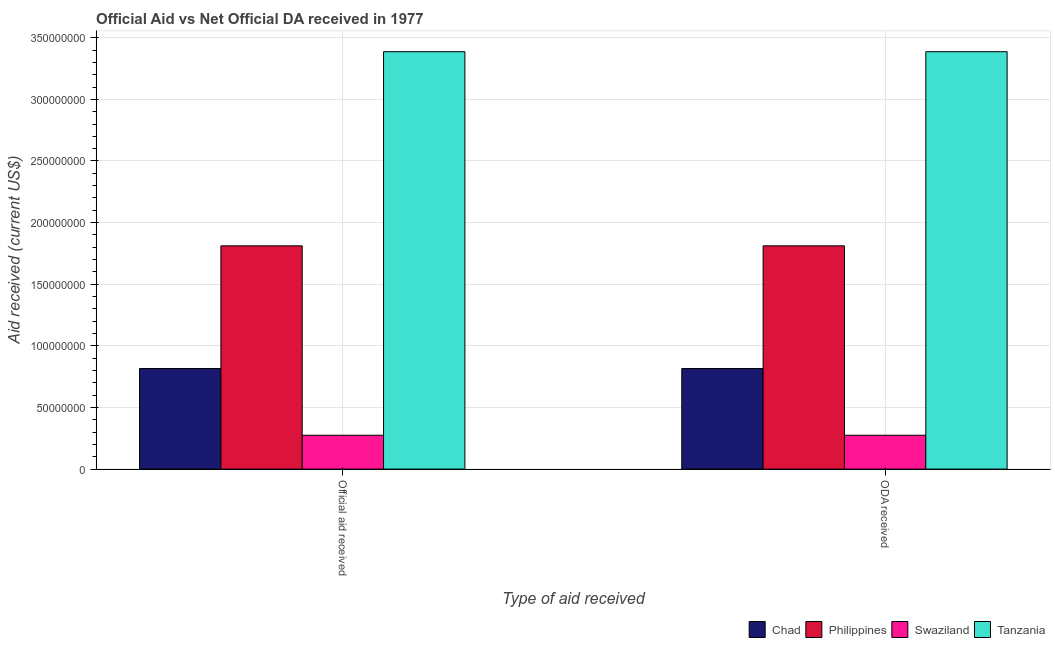How many different coloured bars are there?
Ensure brevity in your answer.  4. How many groups of bars are there?
Provide a succinct answer. 2. Are the number of bars per tick equal to the number of legend labels?
Ensure brevity in your answer.  Yes. Are the number of bars on each tick of the X-axis equal?
Your answer should be compact. Yes. How many bars are there on the 1st tick from the left?
Provide a short and direct response. 4. What is the label of the 2nd group of bars from the left?
Offer a very short reply. ODA received. What is the official aid received in Philippines?
Offer a very short reply. 1.81e+08. Across all countries, what is the maximum oda received?
Your answer should be compact. 3.39e+08. Across all countries, what is the minimum official aid received?
Provide a succinct answer. 2.75e+07. In which country was the oda received maximum?
Offer a terse response. Tanzania. In which country was the oda received minimum?
Give a very brief answer. Swaziland. What is the total oda received in the graph?
Provide a succinct answer. 6.29e+08. What is the difference between the official aid received in Philippines and that in Chad?
Provide a succinct answer. 9.96e+07. What is the difference between the oda received in Swaziland and the official aid received in Philippines?
Provide a succinct answer. -1.54e+08. What is the average official aid received per country?
Make the answer very short. 1.57e+08. In how many countries, is the oda received greater than 20000000 US$?
Your answer should be compact. 4. What is the ratio of the official aid received in Philippines to that in Tanzania?
Your answer should be very brief. 0.53. In how many countries, is the official aid received greater than the average official aid received taken over all countries?
Your answer should be very brief. 2. What does the 1st bar from the left in ODA received represents?
Offer a very short reply. Chad. What does the 2nd bar from the right in Official aid received represents?
Ensure brevity in your answer.  Swaziland. How many bars are there?
Offer a very short reply. 8. Are all the bars in the graph horizontal?
Provide a succinct answer. No. How many countries are there in the graph?
Give a very brief answer. 4. Where does the legend appear in the graph?
Offer a very short reply. Bottom right. How many legend labels are there?
Your answer should be very brief. 4. How are the legend labels stacked?
Provide a short and direct response. Horizontal. What is the title of the graph?
Offer a terse response. Official Aid vs Net Official DA received in 1977 . Does "United Kingdom" appear as one of the legend labels in the graph?
Keep it short and to the point. No. What is the label or title of the X-axis?
Make the answer very short. Type of aid received. What is the label or title of the Y-axis?
Your answer should be very brief. Aid received (current US$). What is the Aid received (current US$) of Chad in Official aid received?
Provide a succinct answer. 8.16e+07. What is the Aid received (current US$) of Philippines in Official aid received?
Your response must be concise. 1.81e+08. What is the Aid received (current US$) of Swaziland in Official aid received?
Make the answer very short. 2.75e+07. What is the Aid received (current US$) of Tanzania in Official aid received?
Your answer should be very brief. 3.39e+08. What is the Aid received (current US$) in Chad in ODA received?
Provide a succinct answer. 8.16e+07. What is the Aid received (current US$) of Philippines in ODA received?
Provide a succinct answer. 1.81e+08. What is the Aid received (current US$) of Swaziland in ODA received?
Provide a succinct answer. 2.75e+07. What is the Aid received (current US$) in Tanzania in ODA received?
Your answer should be compact. 3.39e+08. Across all Type of aid received, what is the maximum Aid received (current US$) in Chad?
Your answer should be compact. 8.16e+07. Across all Type of aid received, what is the maximum Aid received (current US$) in Philippines?
Your response must be concise. 1.81e+08. Across all Type of aid received, what is the maximum Aid received (current US$) of Swaziland?
Give a very brief answer. 2.75e+07. Across all Type of aid received, what is the maximum Aid received (current US$) in Tanzania?
Make the answer very short. 3.39e+08. Across all Type of aid received, what is the minimum Aid received (current US$) in Chad?
Your answer should be very brief. 8.16e+07. Across all Type of aid received, what is the minimum Aid received (current US$) of Philippines?
Give a very brief answer. 1.81e+08. Across all Type of aid received, what is the minimum Aid received (current US$) in Swaziland?
Keep it short and to the point. 2.75e+07. Across all Type of aid received, what is the minimum Aid received (current US$) of Tanzania?
Provide a short and direct response. 3.39e+08. What is the total Aid received (current US$) of Chad in the graph?
Provide a succinct answer. 1.63e+08. What is the total Aid received (current US$) of Philippines in the graph?
Your answer should be compact. 3.62e+08. What is the total Aid received (current US$) in Swaziland in the graph?
Make the answer very short. 5.49e+07. What is the total Aid received (current US$) in Tanzania in the graph?
Make the answer very short. 6.77e+08. What is the difference between the Aid received (current US$) of Swaziland in Official aid received and that in ODA received?
Your answer should be very brief. 0. What is the difference between the Aid received (current US$) of Tanzania in Official aid received and that in ODA received?
Your response must be concise. 0. What is the difference between the Aid received (current US$) of Chad in Official aid received and the Aid received (current US$) of Philippines in ODA received?
Provide a short and direct response. -9.96e+07. What is the difference between the Aid received (current US$) of Chad in Official aid received and the Aid received (current US$) of Swaziland in ODA received?
Your answer should be very brief. 5.41e+07. What is the difference between the Aid received (current US$) in Chad in Official aid received and the Aid received (current US$) in Tanzania in ODA received?
Ensure brevity in your answer.  -2.57e+08. What is the difference between the Aid received (current US$) in Philippines in Official aid received and the Aid received (current US$) in Swaziland in ODA received?
Provide a short and direct response. 1.54e+08. What is the difference between the Aid received (current US$) of Philippines in Official aid received and the Aid received (current US$) of Tanzania in ODA received?
Your response must be concise. -1.58e+08. What is the difference between the Aid received (current US$) in Swaziland in Official aid received and the Aid received (current US$) in Tanzania in ODA received?
Offer a terse response. -3.11e+08. What is the average Aid received (current US$) in Chad per Type of aid received?
Keep it short and to the point. 8.16e+07. What is the average Aid received (current US$) in Philippines per Type of aid received?
Provide a short and direct response. 1.81e+08. What is the average Aid received (current US$) of Swaziland per Type of aid received?
Provide a succinct answer. 2.75e+07. What is the average Aid received (current US$) of Tanzania per Type of aid received?
Keep it short and to the point. 3.39e+08. What is the difference between the Aid received (current US$) in Chad and Aid received (current US$) in Philippines in Official aid received?
Your answer should be compact. -9.96e+07. What is the difference between the Aid received (current US$) in Chad and Aid received (current US$) in Swaziland in Official aid received?
Your answer should be compact. 5.41e+07. What is the difference between the Aid received (current US$) in Chad and Aid received (current US$) in Tanzania in Official aid received?
Provide a succinct answer. -2.57e+08. What is the difference between the Aid received (current US$) of Philippines and Aid received (current US$) of Swaziland in Official aid received?
Provide a short and direct response. 1.54e+08. What is the difference between the Aid received (current US$) in Philippines and Aid received (current US$) in Tanzania in Official aid received?
Your response must be concise. -1.58e+08. What is the difference between the Aid received (current US$) of Swaziland and Aid received (current US$) of Tanzania in Official aid received?
Provide a succinct answer. -3.11e+08. What is the difference between the Aid received (current US$) of Chad and Aid received (current US$) of Philippines in ODA received?
Your answer should be compact. -9.96e+07. What is the difference between the Aid received (current US$) of Chad and Aid received (current US$) of Swaziland in ODA received?
Provide a succinct answer. 5.41e+07. What is the difference between the Aid received (current US$) of Chad and Aid received (current US$) of Tanzania in ODA received?
Provide a short and direct response. -2.57e+08. What is the difference between the Aid received (current US$) of Philippines and Aid received (current US$) of Swaziland in ODA received?
Your answer should be compact. 1.54e+08. What is the difference between the Aid received (current US$) in Philippines and Aid received (current US$) in Tanzania in ODA received?
Make the answer very short. -1.58e+08. What is the difference between the Aid received (current US$) in Swaziland and Aid received (current US$) in Tanzania in ODA received?
Make the answer very short. -3.11e+08. What is the ratio of the Aid received (current US$) of Swaziland in Official aid received to that in ODA received?
Ensure brevity in your answer.  1. What is the ratio of the Aid received (current US$) in Tanzania in Official aid received to that in ODA received?
Offer a very short reply. 1. What is the difference between the highest and the second highest Aid received (current US$) of Philippines?
Your answer should be very brief. 0. What is the difference between the highest and the lowest Aid received (current US$) of Philippines?
Give a very brief answer. 0. 